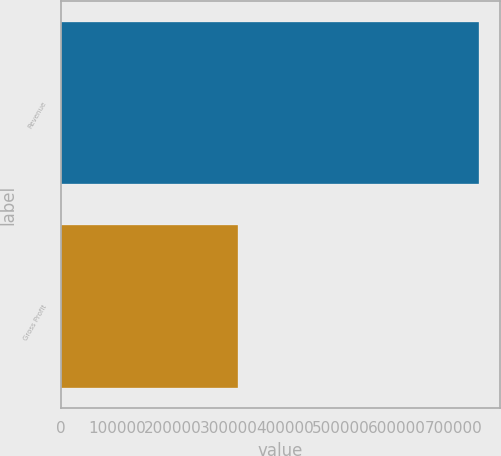<chart> <loc_0><loc_0><loc_500><loc_500><bar_chart><fcel>Revenue<fcel>Gross Profit<nl><fcel>746892<fcel>315994<nl></chart> 